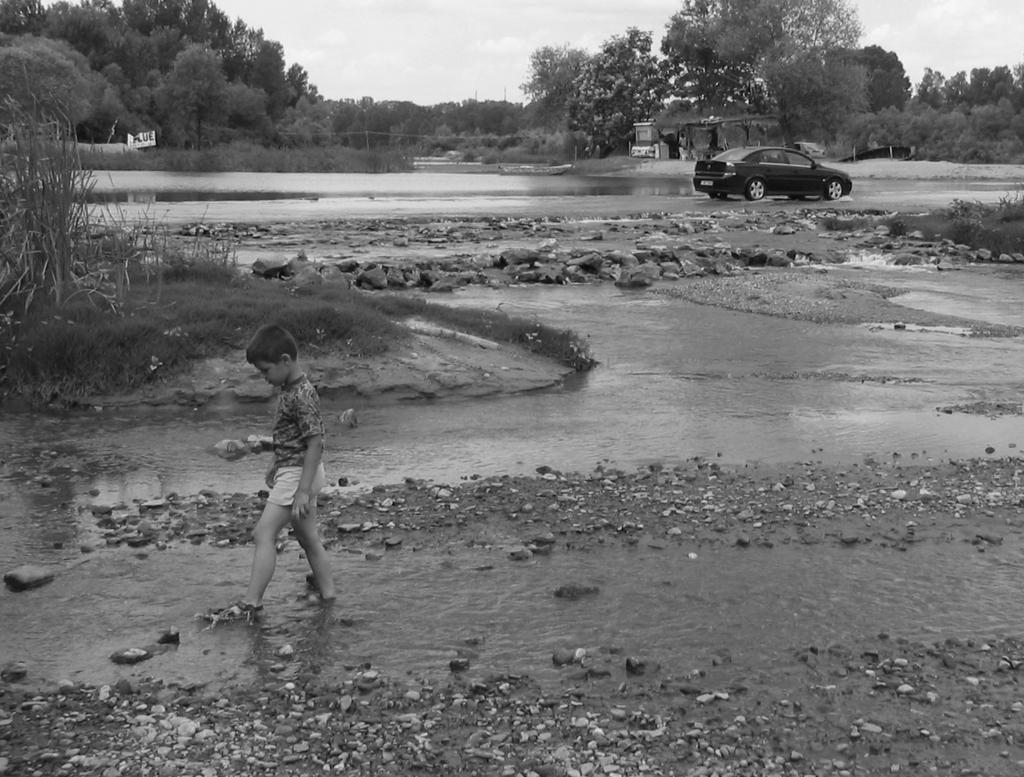How would you summarize this image in a sentence or two? In the picture we can see water surface in it we can see stones and a boy is walking and beside him we can see a path with some grass plants and some far away from it we can see a road on it we can see a car and far away from it we can see plants, trees and behind it we can see the sky. 